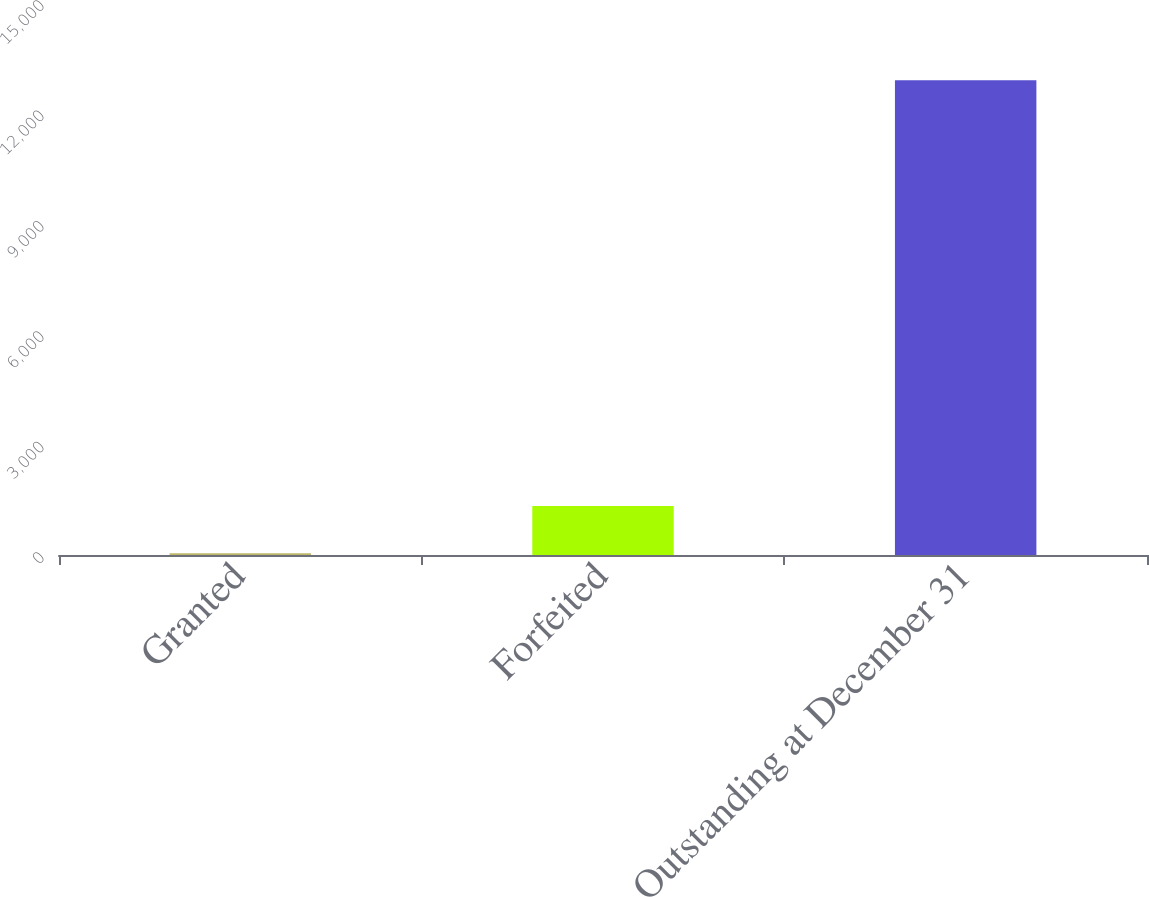<chart> <loc_0><loc_0><loc_500><loc_500><bar_chart><fcel>Granted<fcel>Forfeited<fcel>Outstanding at December 31<nl><fcel>48<fcel>1333.5<fcel>12903<nl></chart> 